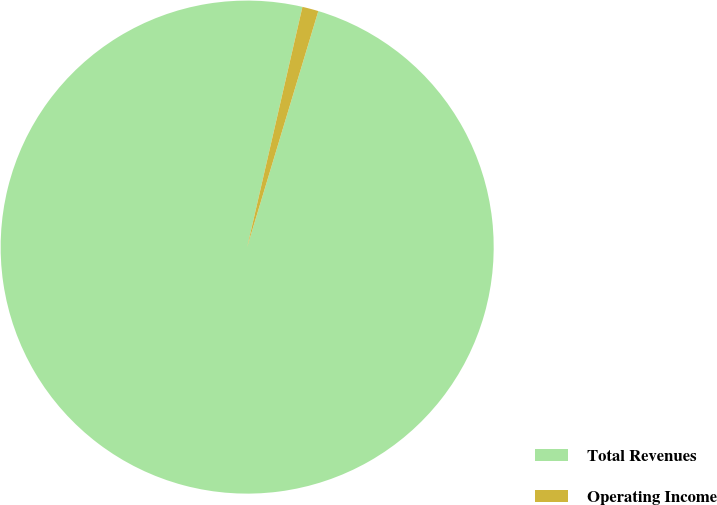Convert chart to OTSL. <chart><loc_0><loc_0><loc_500><loc_500><pie_chart><fcel>Total Revenues<fcel>Operating Income<nl><fcel>98.94%<fcel>1.06%<nl></chart> 